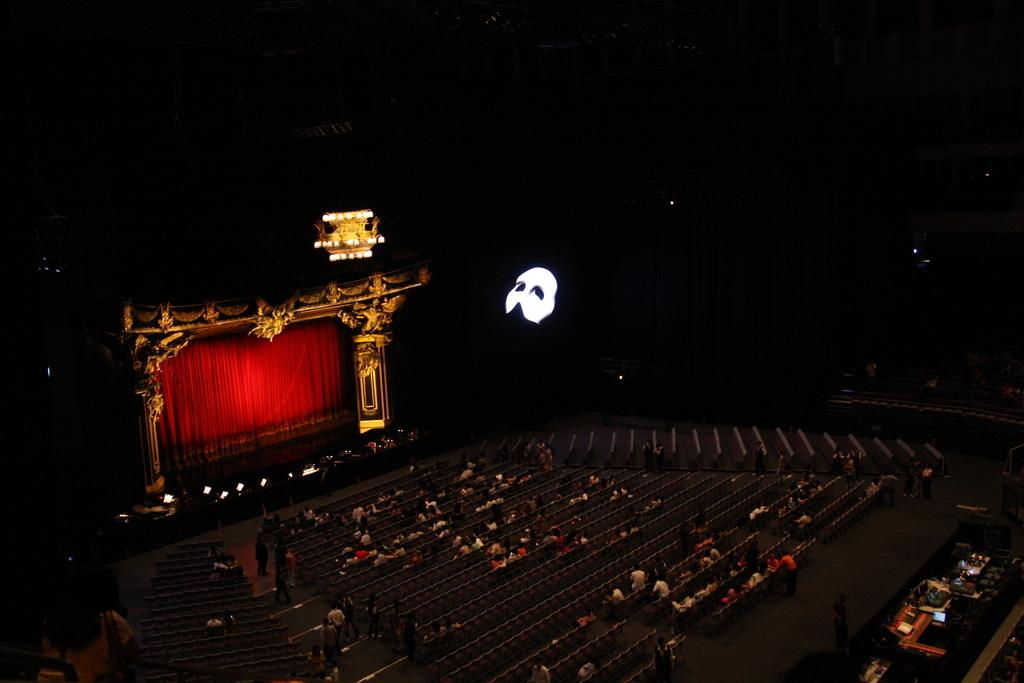What is located in the middle of the image? There is a seating area in the middle of the image. What is happening in the seating area? There are people sitting in the seating area. What can be seen on the left side of the image? There is a stage on the left side of the image. What type of chain can be seen hanging from the lamp in the image? There is no lamp or chain present in the image. What color is the sky in the image? The provided facts do not mention the color of the sky, and there is no indication of the sky being visible in the image. 